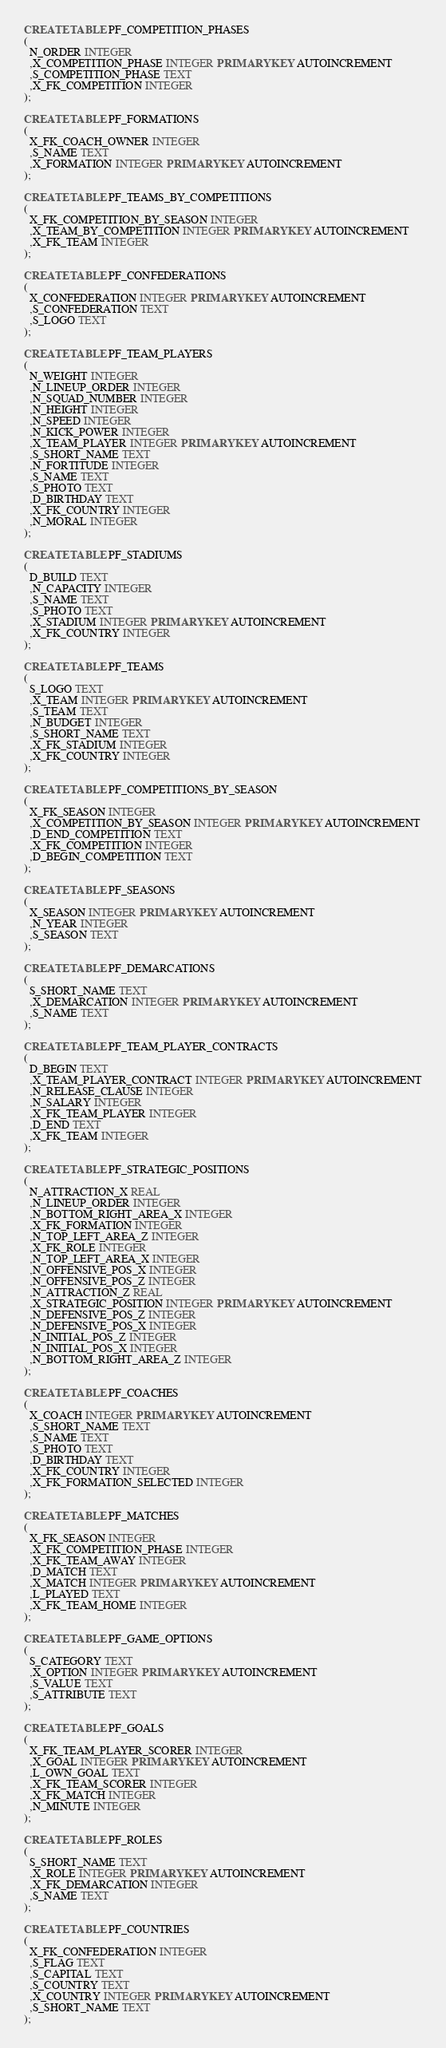<code> <loc_0><loc_0><loc_500><loc_500><_SQL_>CREATE TABLE PF_COMPETITION_PHASES
(
  N_ORDER INTEGER
  ,X_COMPETITION_PHASE INTEGER PRIMARY KEY AUTOINCREMENT
  ,S_COMPETITION_PHASE TEXT
  ,X_FK_COMPETITION INTEGER
);

CREATE TABLE PF_FORMATIONS
(
  X_FK_COACH_OWNER INTEGER
  ,S_NAME TEXT
  ,X_FORMATION INTEGER PRIMARY KEY AUTOINCREMENT
);

CREATE TABLE PF_TEAMS_BY_COMPETITIONS
(
  X_FK_COMPETITION_BY_SEASON INTEGER
  ,X_TEAM_BY_COMPETITION INTEGER PRIMARY KEY AUTOINCREMENT
  ,X_FK_TEAM INTEGER
);

CREATE TABLE PF_CONFEDERATIONS
(
  X_CONFEDERATION INTEGER PRIMARY KEY AUTOINCREMENT
  ,S_CONFEDERATION TEXT
  ,S_LOGO TEXT
);

CREATE TABLE PF_TEAM_PLAYERS
(
  N_WEIGHT INTEGER
  ,N_LINEUP_ORDER INTEGER
  ,N_SQUAD_NUMBER INTEGER
  ,N_HEIGHT INTEGER
  ,N_SPEED INTEGER
  ,N_KICK_POWER INTEGER
  ,X_TEAM_PLAYER INTEGER PRIMARY KEY AUTOINCREMENT
  ,S_SHORT_NAME TEXT
  ,N_FORTITUDE INTEGER
  ,S_NAME TEXT
  ,S_PHOTO TEXT
  ,D_BIRTHDAY TEXT
  ,X_FK_COUNTRY INTEGER
  ,N_MORAL INTEGER
);

CREATE TABLE PF_STADIUMS
(
  D_BUILD TEXT
  ,N_CAPACITY INTEGER
  ,S_NAME TEXT
  ,S_PHOTO TEXT
  ,X_STADIUM INTEGER PRIMARY KEY AUTOINCREMENT
  ,X_FK_COUNTRY INTEGER
);

CREATE TABLE PF_TEAMS
(
  S_LOGO TEXT
  ,X_TEAM INTEGER PRIMARY KEY AUTOINCREMENT
  ,S_TEAM TEXT
  ,N_BUDGET INTEGER
  ,S_SHORT_NAME TEXT
  ,X_FK_STADIUM INTEGER
  ,X_FK_COUNTRY INTEGER
);

CREATE TABLE PF_COMPETITIONS_BY_SEASON
(
  X_FK_SEASON INTEGER
  ,X_COMPETITION_BY_SEASON INTEGER PRIMARY KEY AUTOINCREMENT
  ,D_END_COMPETITION TEXT
  ,X_FK_COMPETITION INTEGER
  ,D_BEGIN_COMPETITION TEXT
);

CREATE TABLE PF_SEASONS
(
  X_SEASON INTEGER PRIMARY KEY AUTOINCREMENT
  ,N_YEAR INTEGER
  ,S_SEASON TEXT
);

CREATE TABLE PF_DEMARCATIONS
(
  S_SHORT_NAME TEXT
  ,X_DEMARCATION INTEGER PRIMARY KEY AUTOINCREMENT
  ,S_NAME TEXT
);

CREATE TABLE PF_TEAM_PLAYER_CONTRACTS
(
  D_BEGIN TEXT
  ,X_TEAM_PLAYER_CONTRACT INTEGER PRIMARY KEY AUTOINCREMENT
  ,N_RELEASE_CLAUSE INTEGER
  ,N_SALARY INTEGER
  ,X_FK_TEAM_PLAYER INTEGER
  ,D_END TEXT
  ,X_FK_TEAM INTEGER
);

CREATE TABLE PF_STRATEGIC_POSITIONS
(
  N_ATTRACTION_X REAL
  ,N_LINEUP_ORDER INTEGER
  ,N_BOTTOM_RIGHT_AREA_X INTEGER
  ,X_FK_FORMATION INTEGER
  ,N_TOP_LEFT_AREA_Z INTEGER
  ,X_FK_ROLE INTEGER
  ,N_TOP_LEFT_AREA_X INTEGER
  ,N_OFFENSIVE_POS_X INTEGER
  ,N_OFFENSIVE_POS_Z INTEGER
  ,N_ATTRACTION_Z REAL
  ,X_STRATEGIC_POSITION INTEGER PRIMARY KEY AUTOINCREMENT
  ,N_DEFENSIVE_POS_Z INTEGER
  ,N_DEFENSIVE_POS_X INTEGER
  ,N_INITIAL_POS_Z INTEGER
  ,N_INITIAL_POS_X INTEGER
  ,N_BOTTOM_RIGHT_AREA_Z INTEGER
);

CREATE TABLE PF_COACHES
(
  X_COACH INTEGER PRIMARY KEY AUTOINCREMENT
  ,S_SHORT_NAME TEXT
  ,S_NAME TEXT
  ,S_PHOTO TEXT
  ,D_BIRTHDAY TEXT
  ,X_FK_COUNTRY INTEGER
  ,X_FK_FORMATION_SELECTED INTEGER
);

CREATE TABLE PF_MATCHES
(
  X_FK_SEASON INTEGER
  ,X_FK_COMPETITION_PHASE INTEGER
  ,X_FK_TEAM_AWAY INTEGER
  ,D_MATCH TEXT
  ,X_MATCH INTEGER PRIMARY KEY AUTOINCREMENT
  ,L_PLAYED TEXT
  ,X_FK_TEAM_HOME INTEGER
);

CREATE TABLE PF_GAME_OPTIONS
(
  S_CATEGORY TEXT
  ,X_OPTION INTEGER PRIMARY KEY AUTOINCREMENT
  ,S_VALUE TEXT
  ,S_ATTRIBUTE TEXT
);

CREATE TABLE PF_GOALS
(
  X_FK_TEAM_PLAYER_SCORER INTEGER
  ,X_GOAL INTEGER PRIMARY KEY AUTOINCREMENT
  ,L_OWN_GOAL TEXT
  ,X_FK_TEAM_SCORER INTEGER
  ,X_FK_MATCH INTEGER
  ,N_MINUTE INTEGER
);

CREATE TABLE PF_ROLES
(
  S_SHORT_NAME TEXT
  ,X_ROLE INTEGER PRIMARY KEY AUTOINCREMENT
  ,X_FK_DEMARCATION INTEGER
  ,S_NAME TEXT
);

CREATE TABLE PF_COUNTRIES
(
  X_FK_CONFEDERATION INTEGER
  ,S_FLAG TEXT
  ,S_CAPITAL TEXT
  ,S_COUNTRY TEXT
  ,X_COUNTRY INTEGER PRIMARY KEY AUTOINCREMENT
  ,S_SHORT_NAME TEXT
);
</code> 